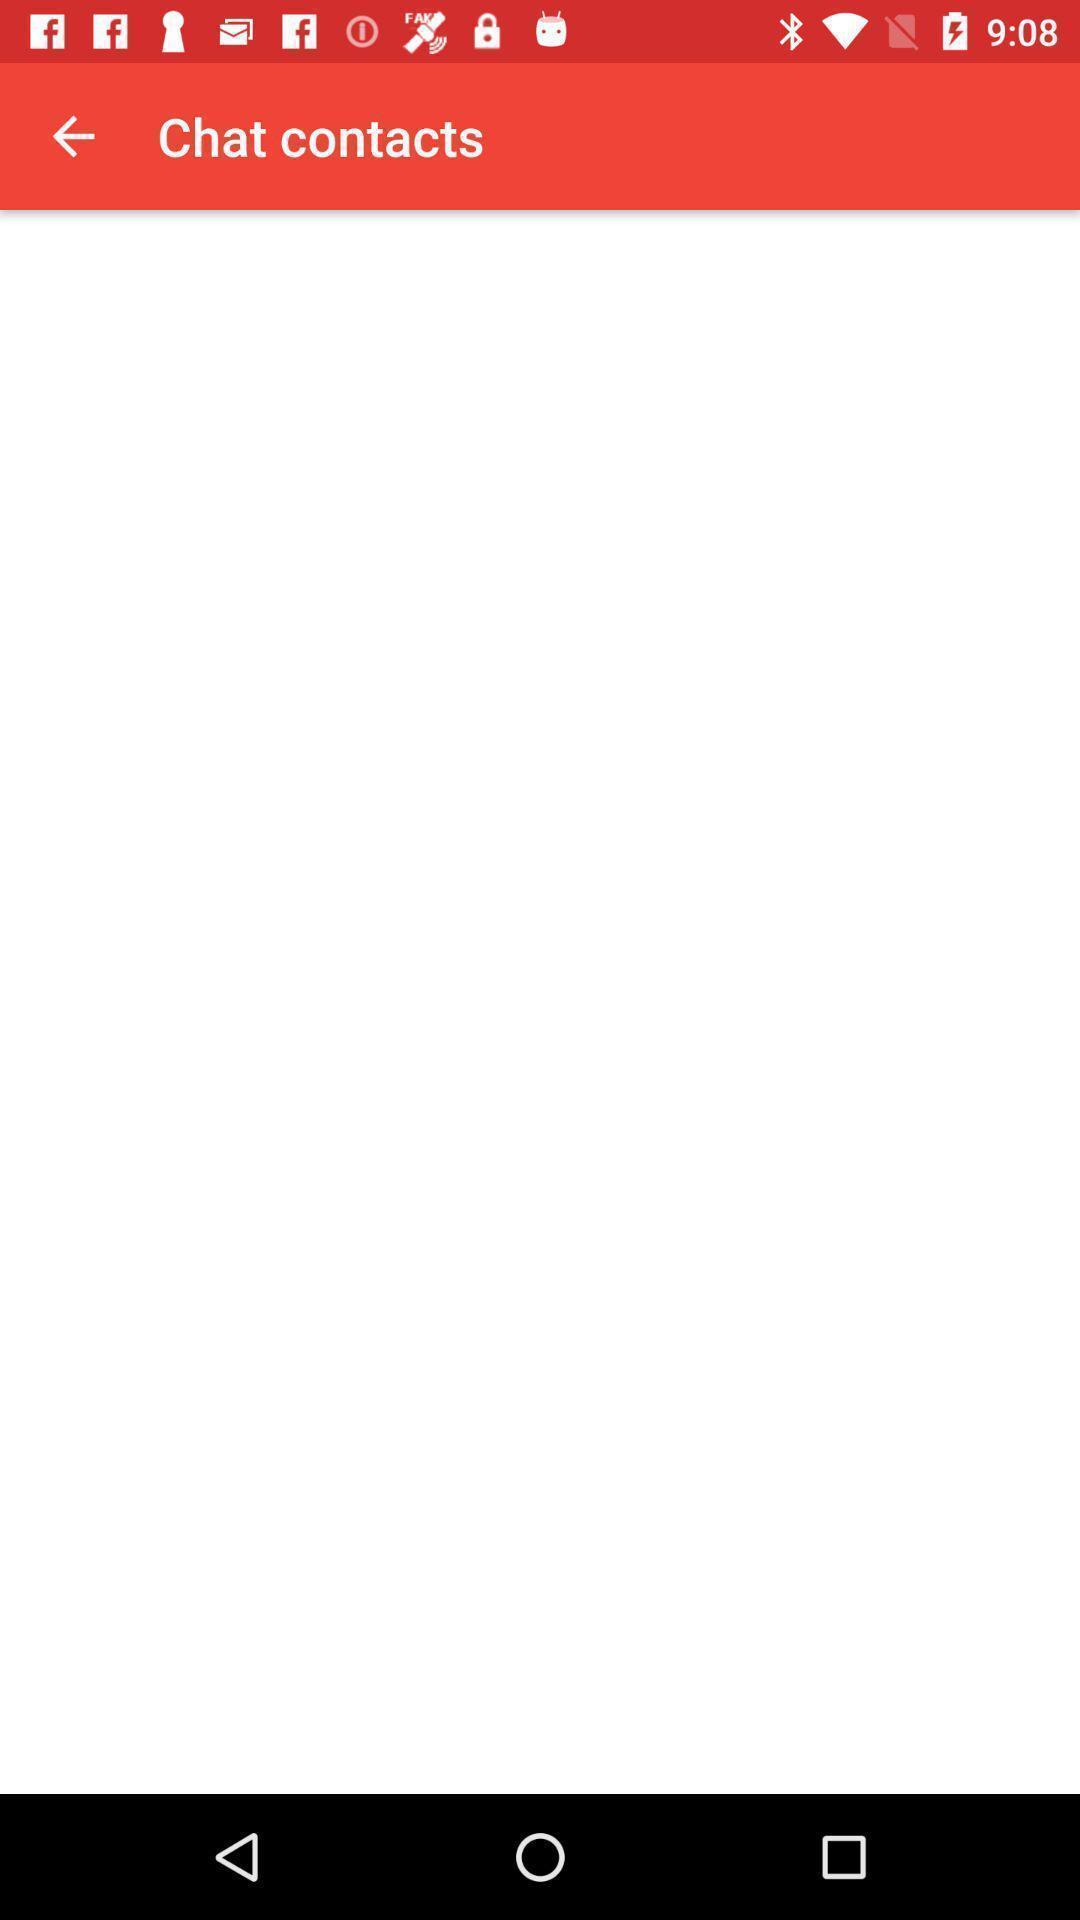Describe the content in this image. Page displaying chat contact informations. 